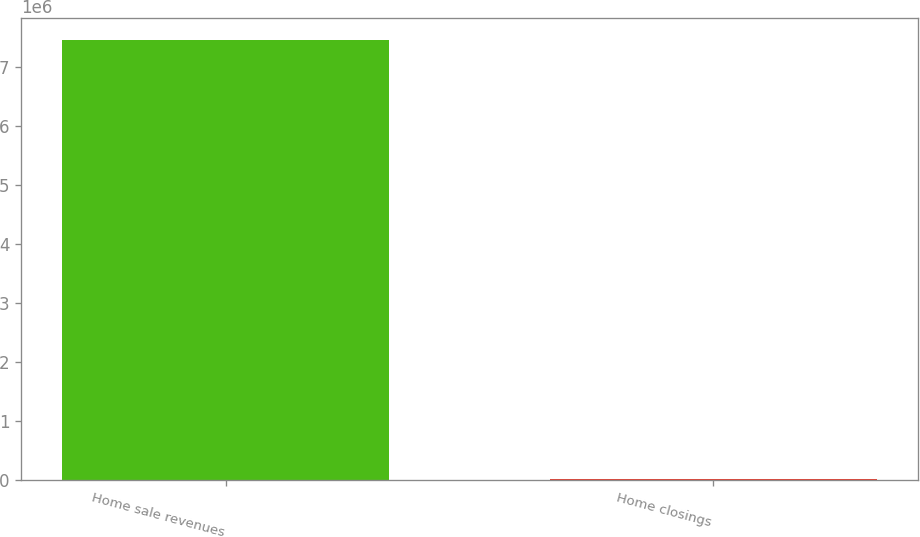Convert chart. <chart><loc_0><loc_0><loc_500><loc_500><bar_chart><fcel>Home sale revenues<fcel>Home closings<nl><fcel>7.45132e+06<fcel>19951<nl></chart> 